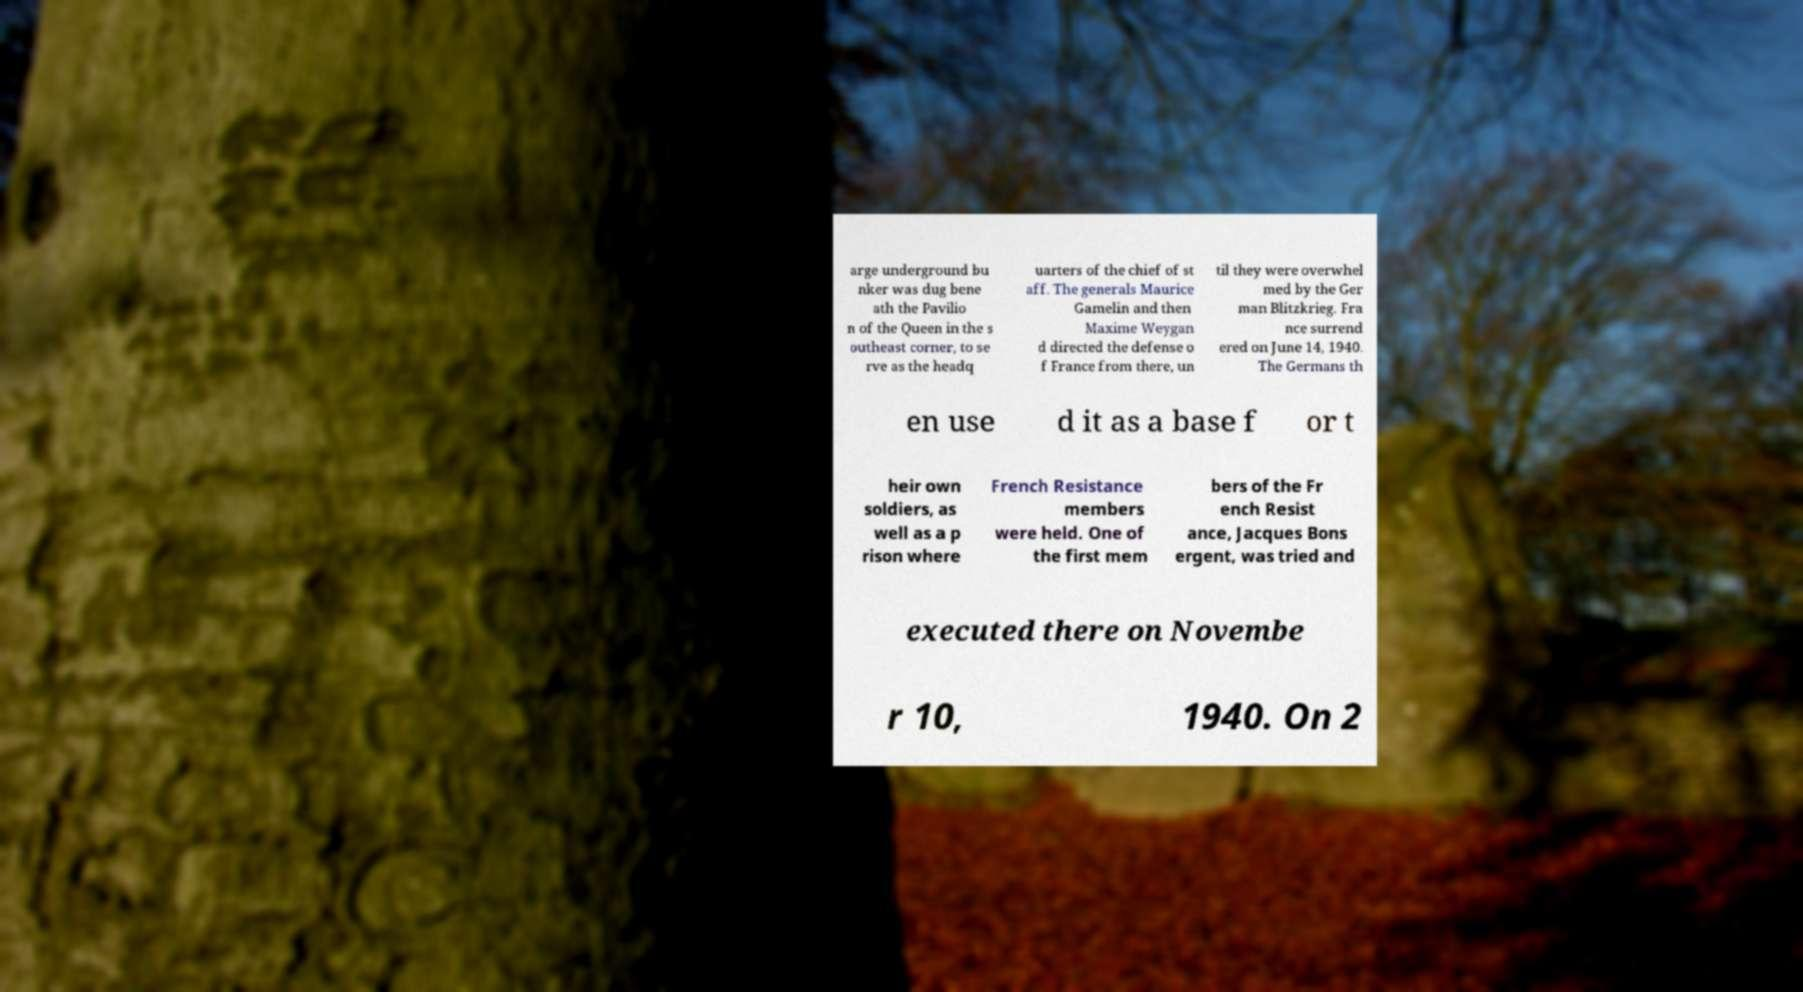I need the written content from this picture converted into text. Can you do that? arge underground bu nker was dug bene ath the Pavilio n of the Queen in the s outheast corner, to se rve as the headq uarters of the chief of st aff. The generals Maurice Gamelin and then Maxime Weygan d directed the defense o f France from there, un til they were overwhel med by the Ger man Blitzkrieg. Fra nce surrend ered on June 14, 1940. The Germans th en use d it as a base f or t heir own soldiers, as well as a p rison where French Resistance members were held. One of the first mem bers of the Fr ench Resist ance, Jacques Bons ergent, was tried and executed there on Novembe r 10, 1940. On 2 